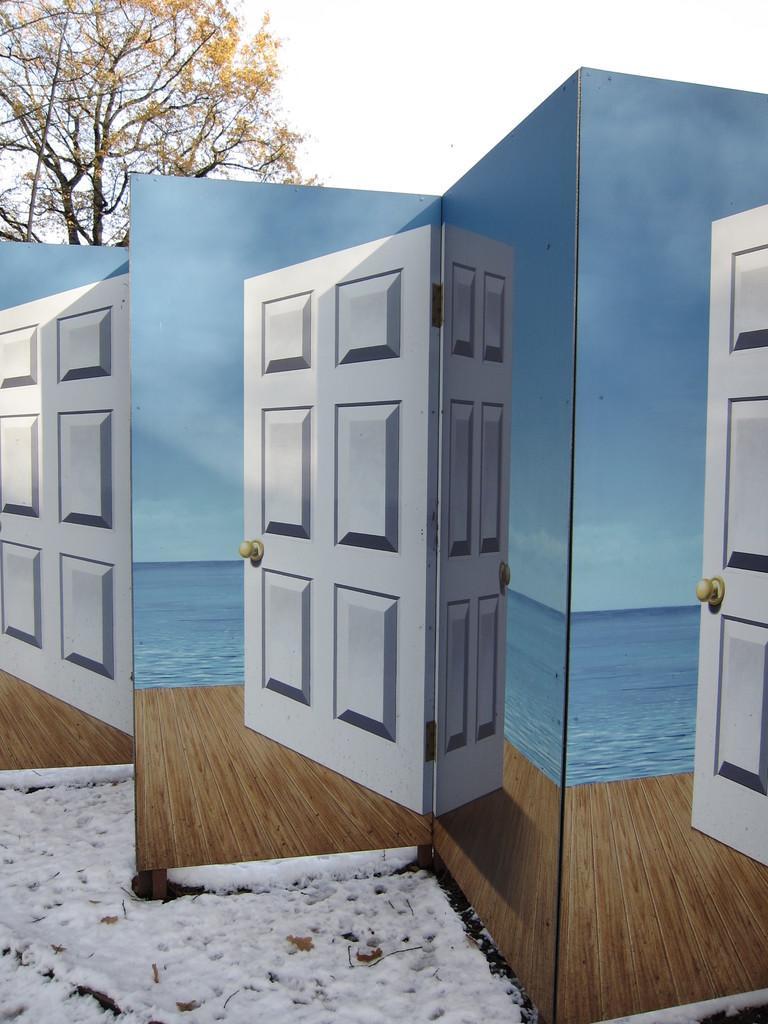Could you give a brief overview of what you see in this image? In this picture we can see there are boards and on the boards there are doors, wooden floor and water. Behind the boards, there is a tree and a sky. 